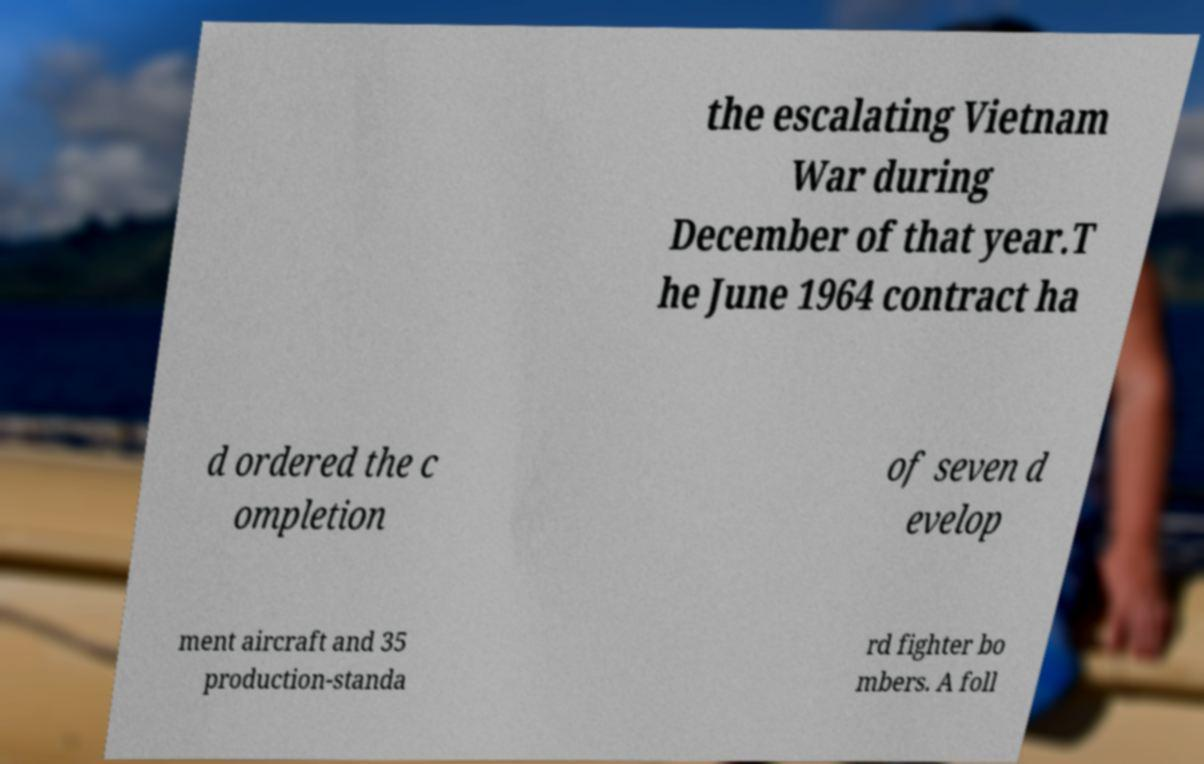Can you read and provide the text displayed in the image?This photo seems to have some interesting text. Can you extract and type it out for me? the escalating Vietnam War during December of that year.T he June 1964 contract ha d ordered the c ompletion of seven d evelop ment aircraft and 35 production-standa rd fighter bo mbers. A foll 